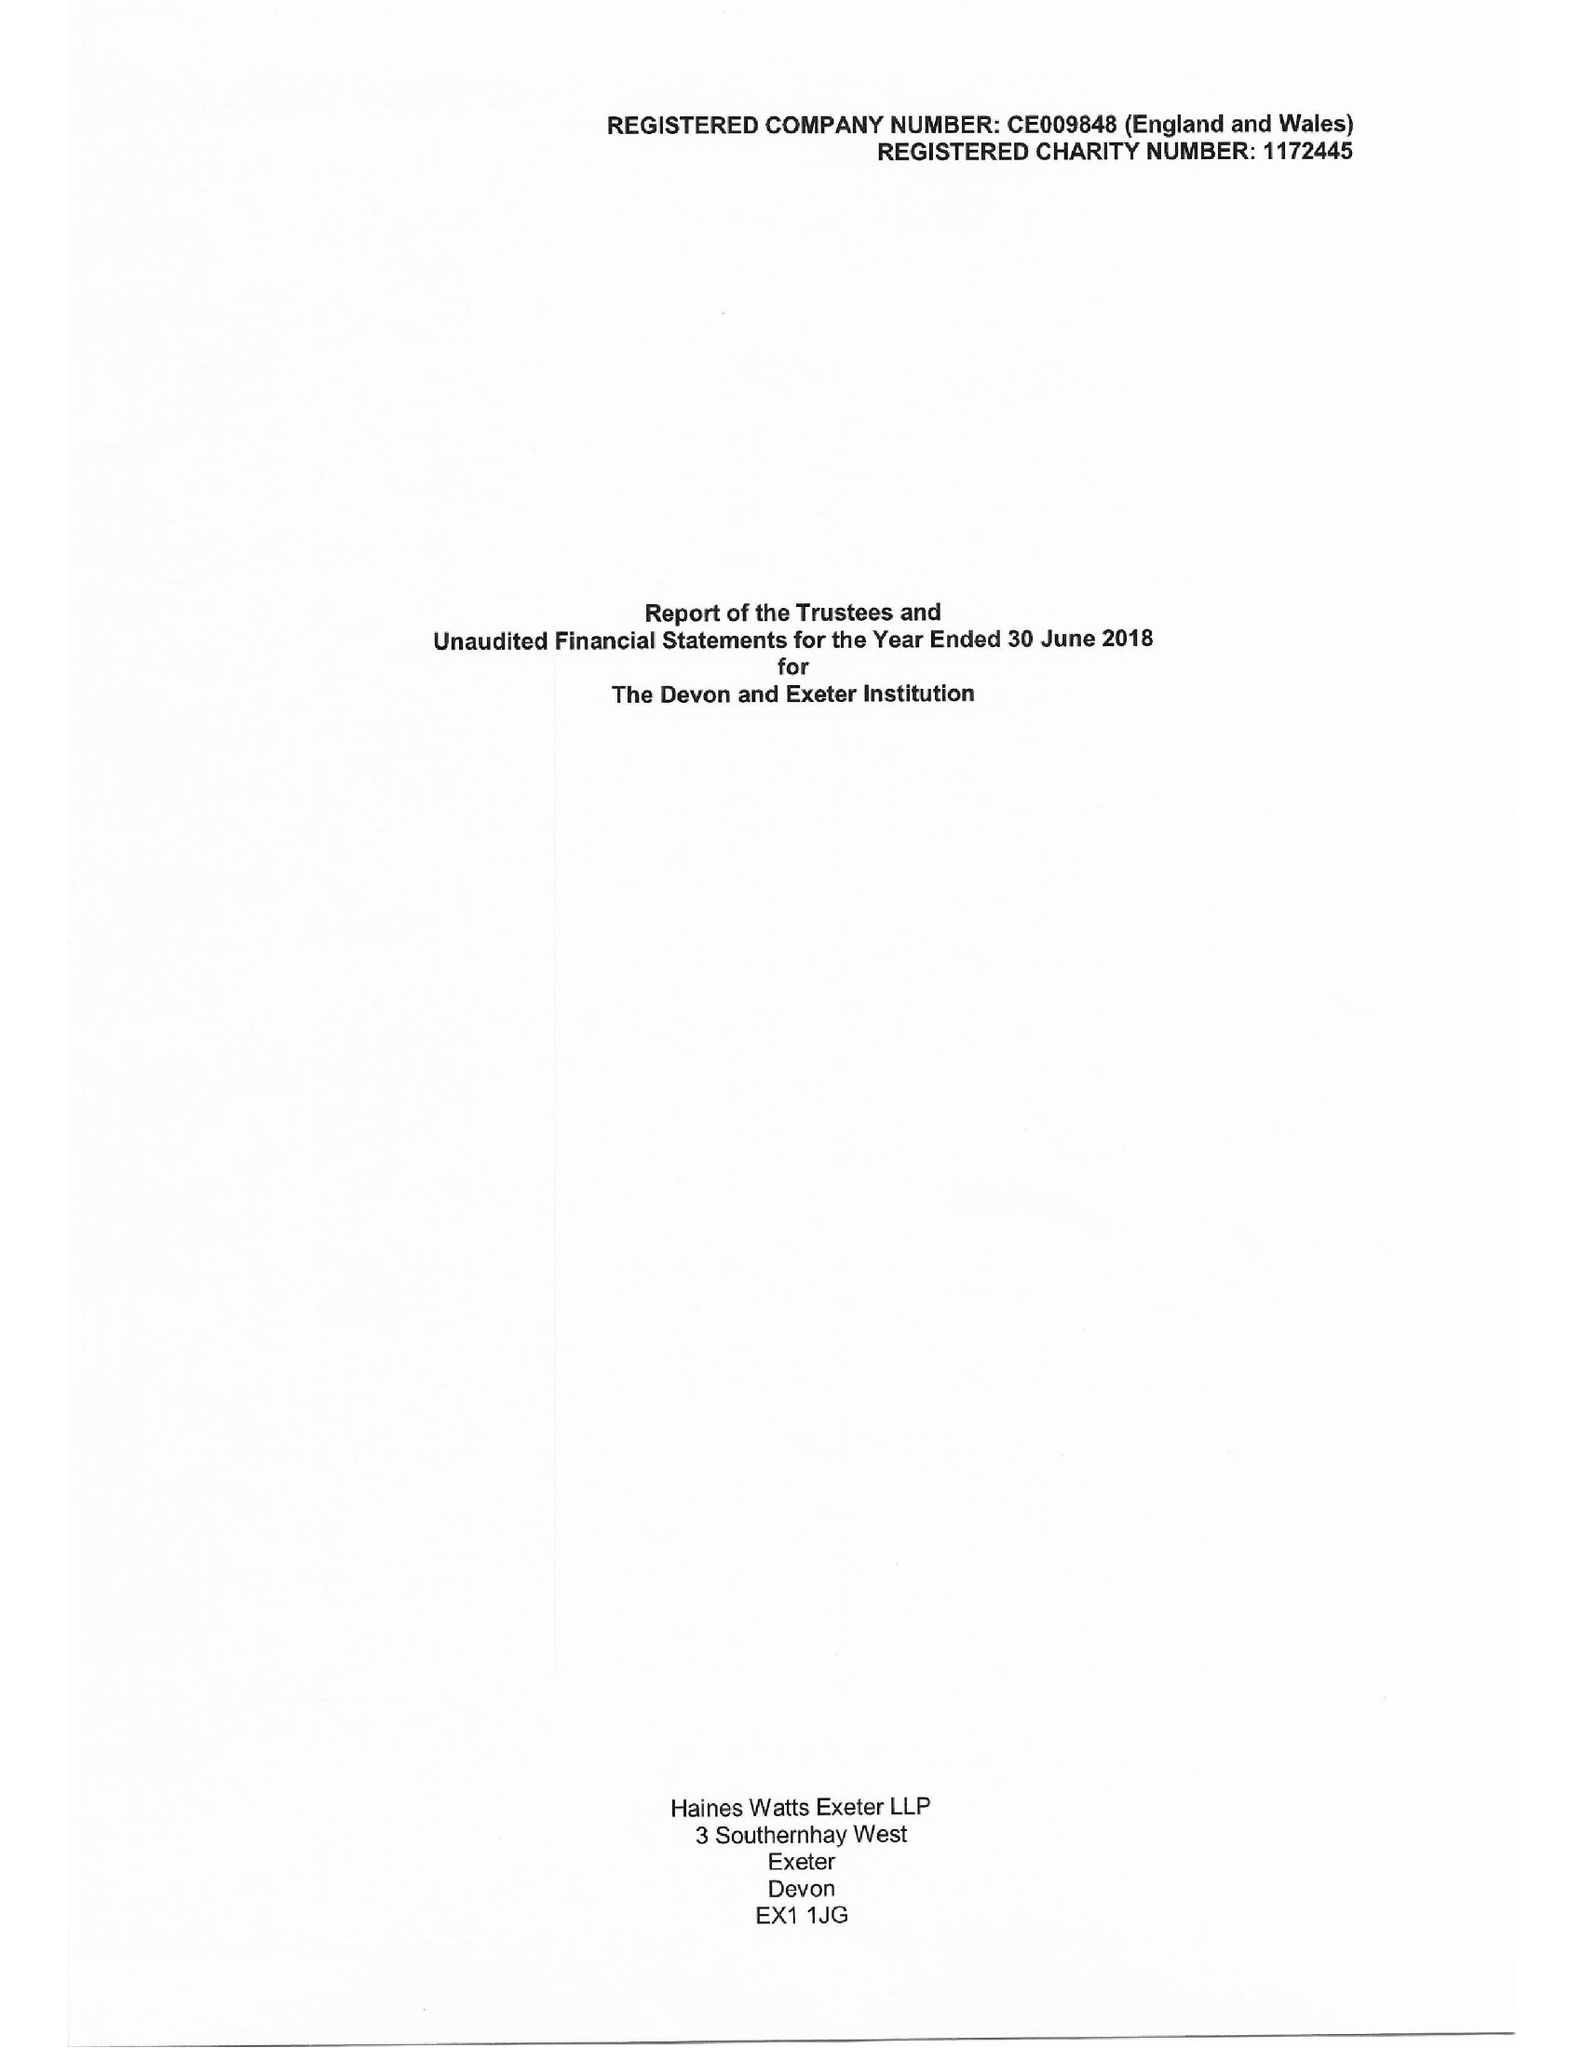What is the value for the charity_name?
Answer the question using a single word or phrase. The Devon and Exeter Institution 